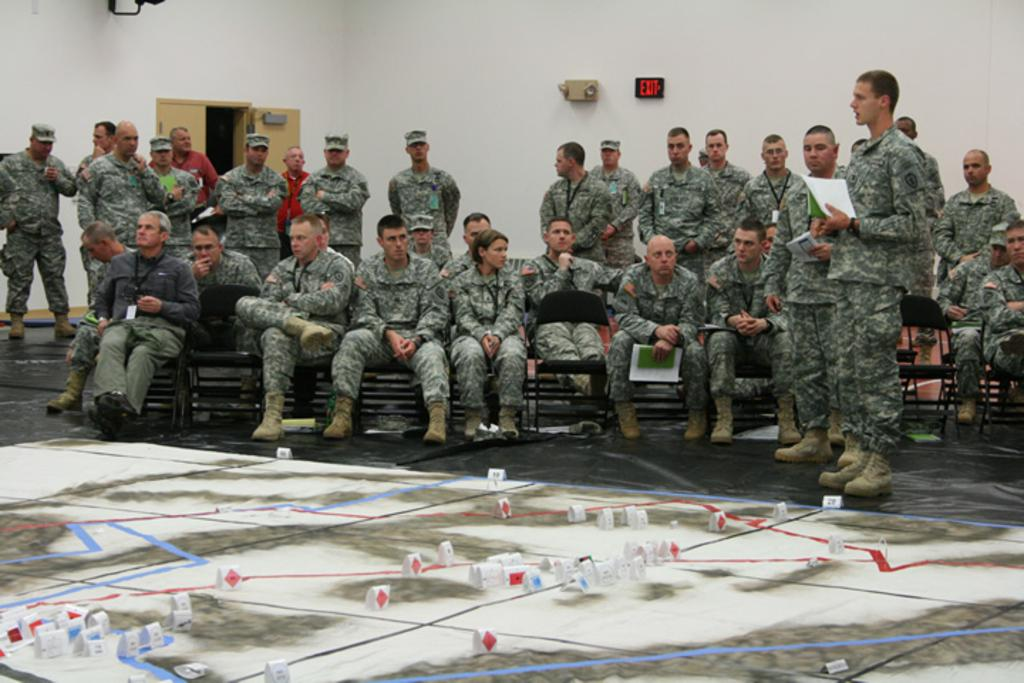What are the people in the image doing? There are groups of people standing in the image. What can be seen attached to the wall in the image? There is an exit board attached to the wall. What is a feature of the room or space depicted in the image? There is a door in the image. What type of object is placed on the floor in the image? There is a map placed on the floor. Are the people wearing masks in the image? There is no mention of masks in the image, so we cannot determine if the people are wearing them. 